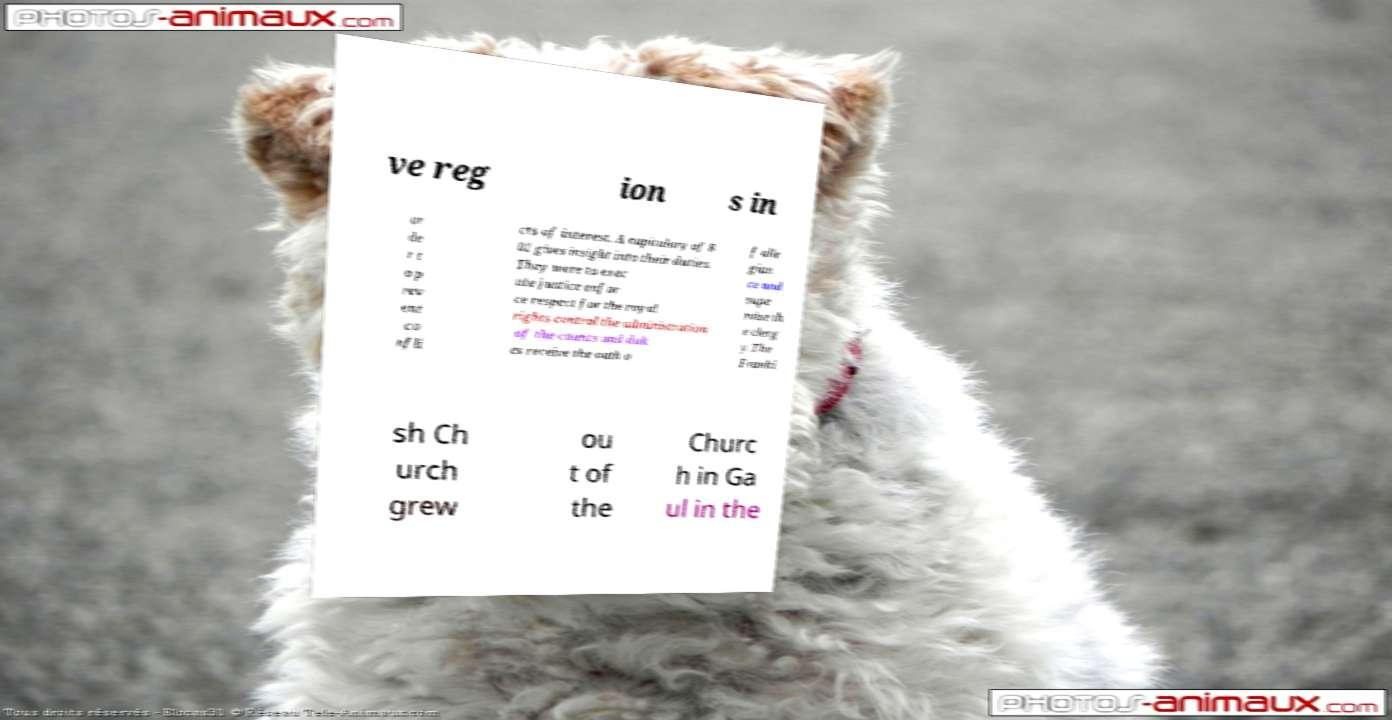Can you accurately transcribe the text from the provided image for me? ve reg ion s in or de r t o p rev ent co nfli cts of interest. A capitulary of 8 02 gives insight into their duties. They were to exec ute justice enfor ce respect for the royal rights control the administration of the counts and duk es receive the oath o f alle gian ce and supe rvise th e clerg y.The Franki sh Ch urch grew ou t of the Churc h in Ga ul in the 